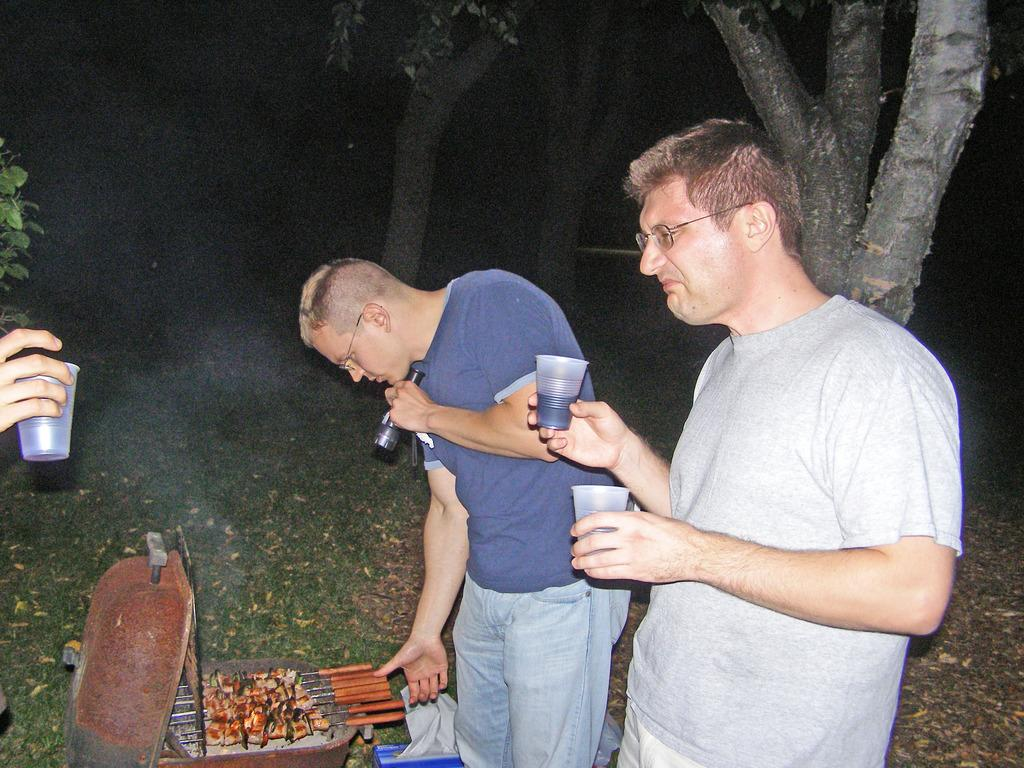What are the men in the image doing? The men in the image are standing and holding glasses. What might be in the glasses they are holding? It is not specified what is in the glasses, but they are holding them. What else can be seen in the image besides the men? There are food items in a container and trees visible in the image. Can you see the men's breath in the image? There is no information about the temperature or weather conditions in the image, so it is not possible to determine if the men's breath is visible. 